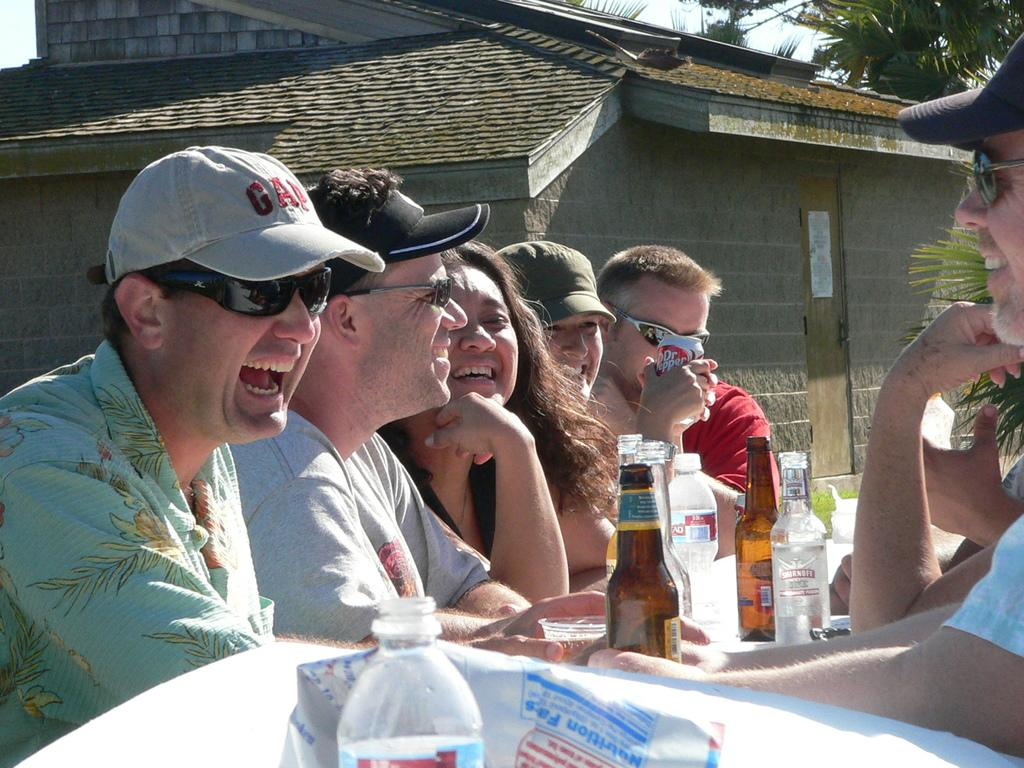What are the people in the image doing? The people in the image are sitting. What objects can be seen near the people? There are bottles visible in the image. What can be seen in the distance behind the people? There is a house, trees, and the sky visible in the background of the image. What type of cork can be seen floating in the water near the people? There is no water or cork present in the image; it features people sitting with bottles in the foreground and a house, trees, and sky in the background. 